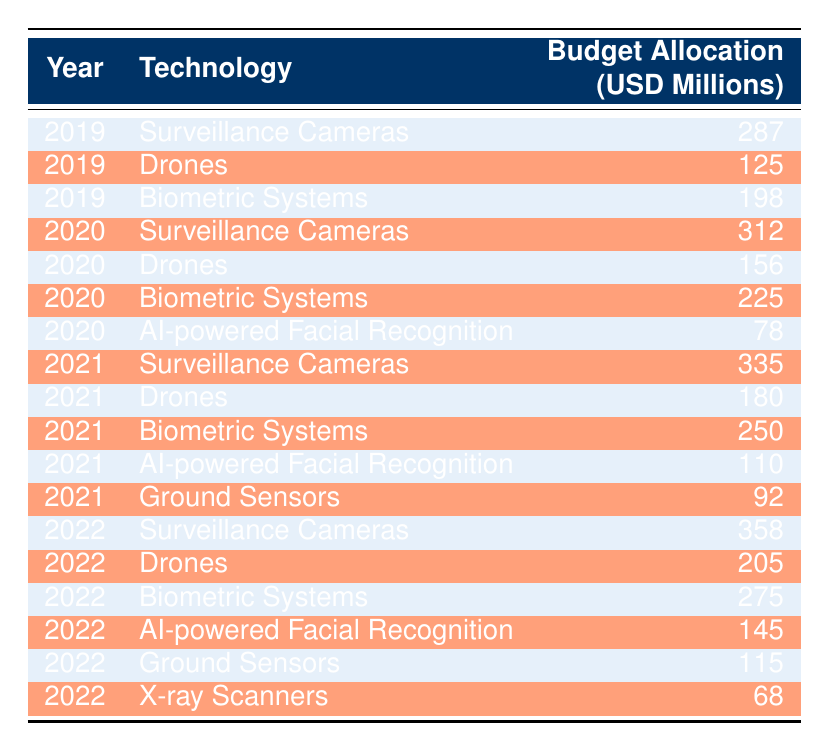What is the budget allocation for drones in 2020? In the data for 2020, the row corresponding to drones shows a budget allocation of 156 million USD.
Answer: 156 million Which technology had the highest budget in 2022? Looking at the 2022 data, surveillance cameras have the highest budget allocation of 358 million USD.
Answer: Surveillance Cameras What is the total budget allocation for biometric systems from 2019 to 2022? The allocations for biometric systems are: 198 million (2019), 225 million (2020), 250 million (2021), and 275 million (2022). Summing these gives: 198 + 225 + 250 + 275 = 948 million USD.
Answer: 948 million Did the budget for AI-powered facial recognition increase from 2020 to 2021? The budget for AI-powered facial recognition in 2020 was 78 million USD, and in 2021 it increased to 110 million USD. Therefore, it did increase.
Answer: Yes What was the average budget allocation for drones from 2019 to 2022? The budgets for drones are: 125 million (2019), 156 million (2020), 180 million (2021), and 205 million (2022). Summing these gives: 125 + 156 + 180 + 205 = 666 million USD. Dividing by 4 (number of years) gives: 666 / 4 = 166.5 million USD.
Answer: 166.5 million 